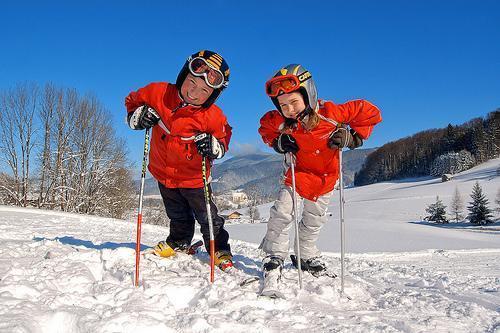How many kids are in the picture?
Give a very brief answer. 2. 